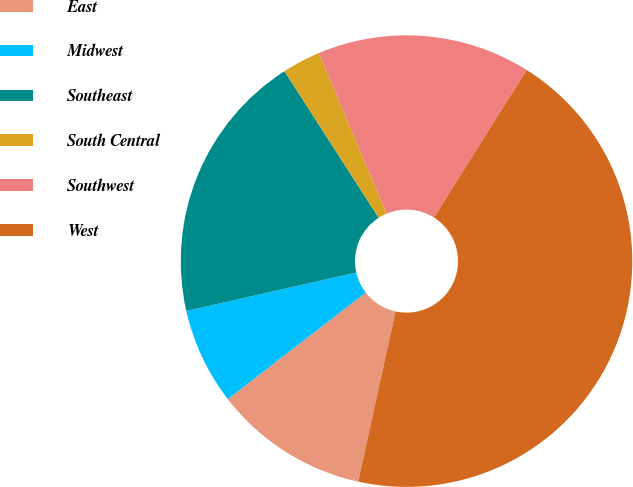Convert chart. <chart><loc_0><loc_0><loc_500><loc_500><pie_chart><fcel>East<fcel>Midwest<fcel>Southeast<fcel>South Central<fcel>Southwest<fcel>West<nl><fcel>11.1%<fcel>6.92%<fcel>19.45%<fcel>2.75%<fcel>15.27%<fcel>44.5%<nl></chart> 